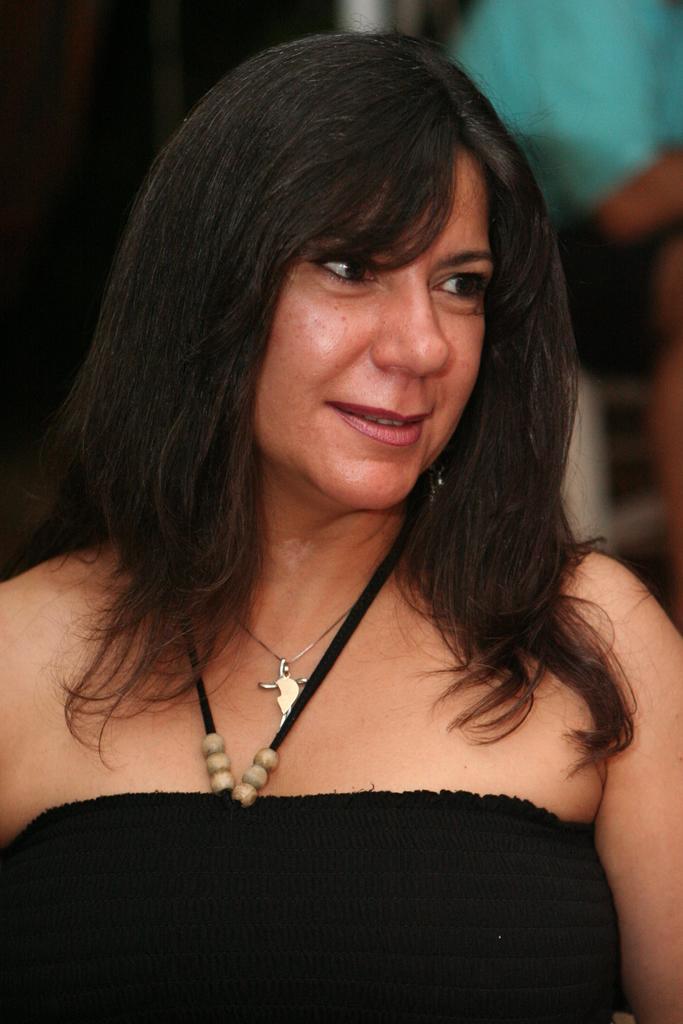Could you give a brief overview of what you see in this image? In this image we can see a woman wearing a black dress and in the background the image is blurred. 